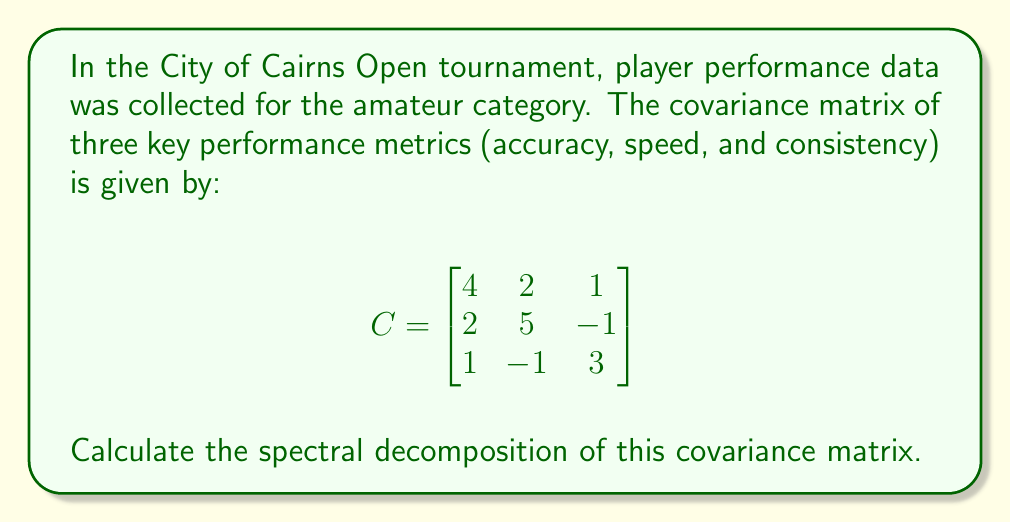Solve this math problem. To find the spectral decomposition of the covariance matrix $C$, we need to follow these steps:

1) Find the eigenvalues of $C$:
   Solve the characteristic equation $\det(C - \lambda I) = 0$
   
   $$\begin{vmatrix}
   4-\lambda & 2 & 1 \\
   2 & 5-\lambda & -1 \\
   1 & -1 & 3-\lambda
   \end{vmatrix} = 0$$
   
   This yields the equation: $-\lambda^3 + 12\lambda^2 - 41\lambda + 42 = 0$
   Solving this, we get: $\lambda_1 = 7$, $\lambda_2 = 3$, $\lambda_3 = 2$

2) Find the eigenvectors for each eigenvalue:
   For $\lambda_1 = 7$: $\vec{v}_1 = [2, 2, 1]^T$
   For $\lambda_2 = 3$: $\vec{v}_2 = [-1, 0, 1]^T$
   For $\lambda_3 = 2$: $\vec{v}_3 = [1, -2, 1]^T$

3) Normalize the eigenvectors:
   $\vec{u}_1 = \frac{1}{\sqrt{9}}[2, 2, 1]^T$
   $\vec{u}_2 = \frac{1}{\sqrt{2}}[-1, 0, 1]^T$
   $\vec{u}_3 = \frac{1}{\sqrt{6}}[1, -2, 1]^T$

4) Form the orthogonal matrix $U$ from the normalized eigenvectors:
   $$U = [\vec{u}_1 \vec{u}_2 \vec{u}_3] = \begin{bmatrix}
   \frac{2}{3} & -\frac{1}{\sqrt{2}} & \frac{1}{\sqrt{6}} \\
   \frac{2}{3} & 0 & -\frac{2}{\sqrt{6}} \\
   \frac{1}{3} & \frac{1}{\sqrt{2}} & \frac{1}{\sqrt{6}}
   \end{bmatrix}$$

5) Form the diagonal matrix $\Lambda$ from the eigenvalues:
   $$\Lambda = \begin{bmatrix}
   7 & 0 & 0 \\
   0 & 3 & 0 \\
   0 & 0 & 2
   \end{bmatrix}$$

The spectral decomposition is then given by $C = U\Lambda U^T$.
Answer: $C = U\Lambda U^T$, where $U = [\frac{2}{3}, -\frac{1}{\sqrt{2}}, \frac{1}{\sqrt{6}}; \frac{2}{3}, 0, -\frac{2}{\sqrt{6}}; \frac{1}{3}, \frac{1}{\sqrt{2}}, \frac{1}{\sqrt{6}}]$ and $\Lambda = \text{diag}(7, 3, 2)$ 